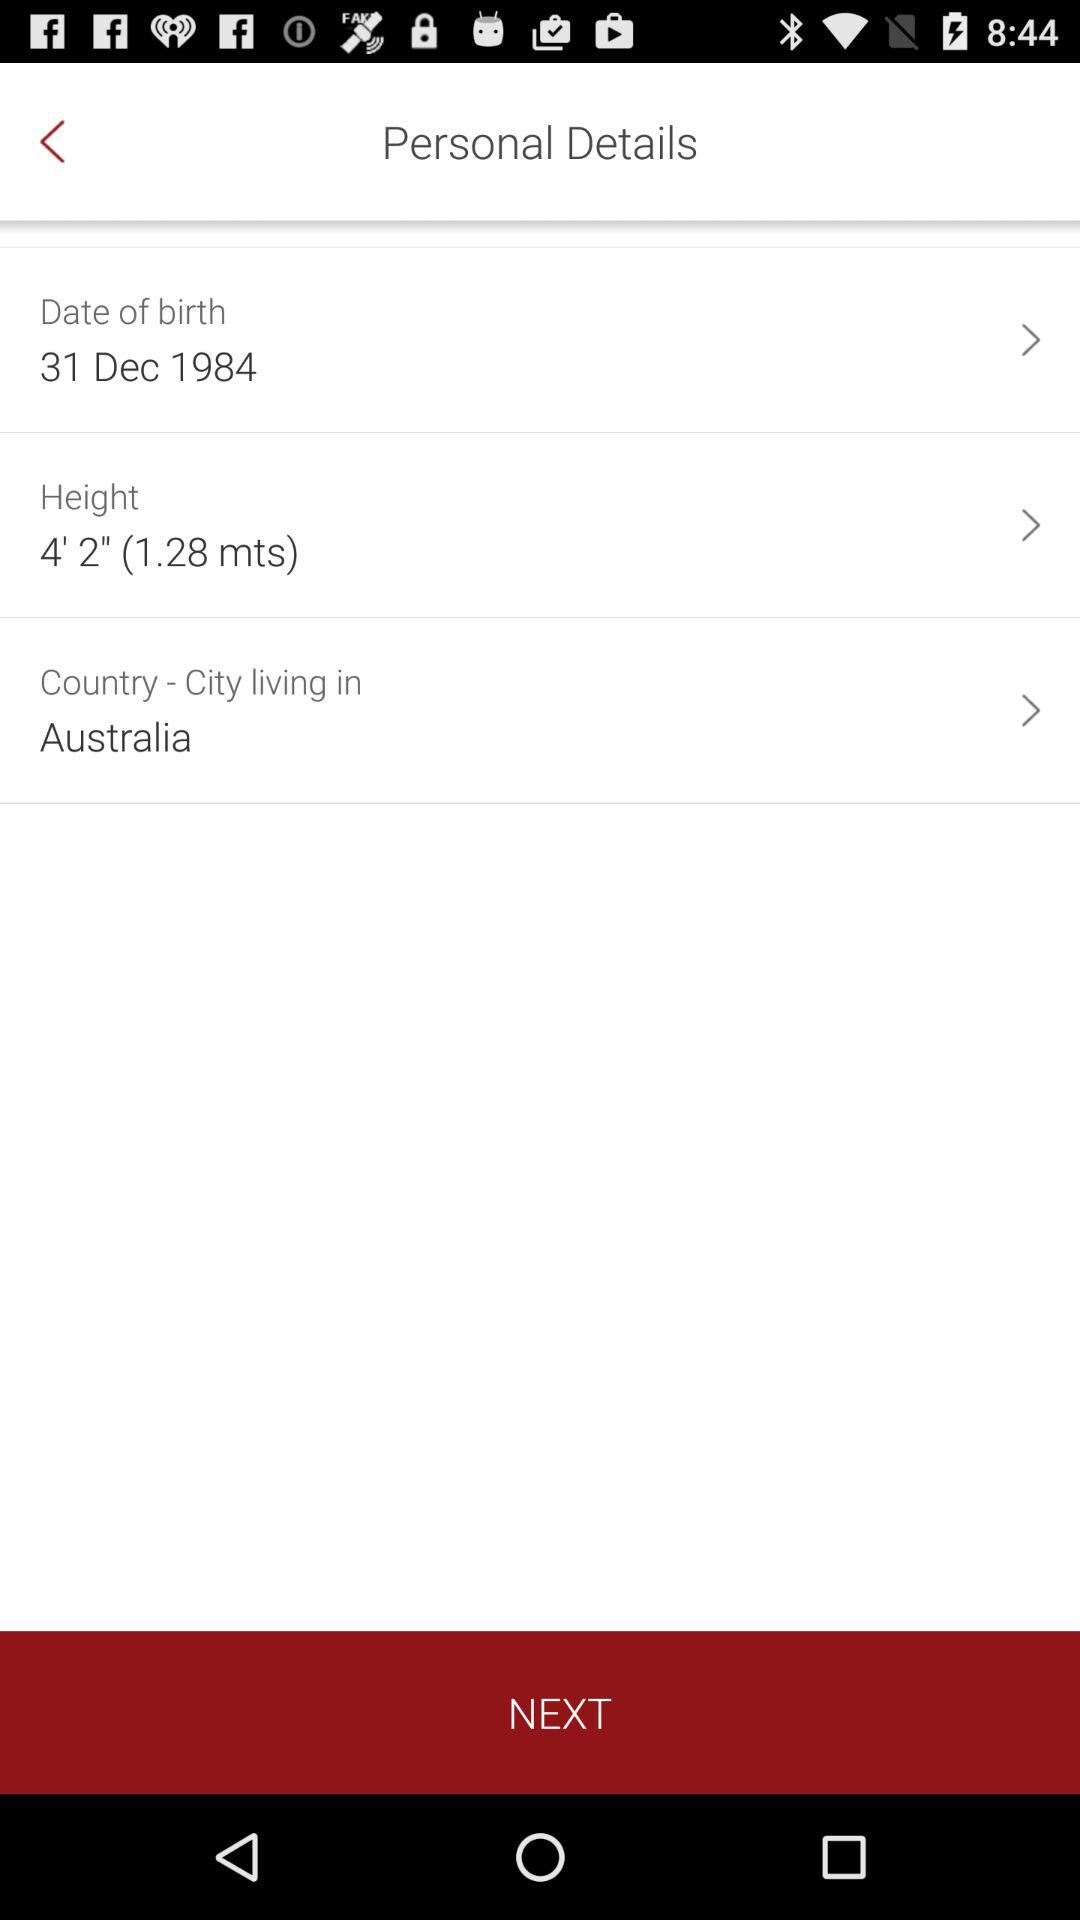What is the date of birth? The date of birth is December 31, 1984. 